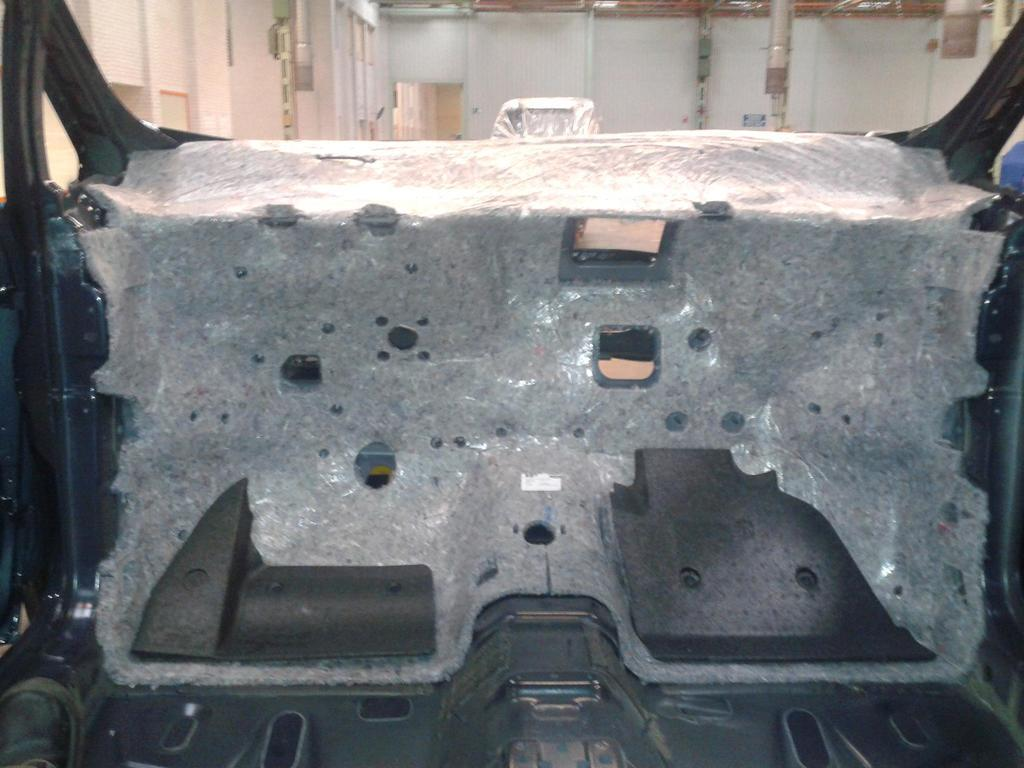What is the main subject of the image? The main subject of the image is a car structural frame. Can you describe the background of the image? There is a wall in the background of the image. Can you see a squirrel climbing the car structural frame in the image? There is no squirrel present in the image; it only features a car structural frame and a wall in the background. 